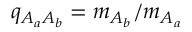<formula> <loc_0><loc_0><loc_500><loc_500>q _ { A _ { a } A _ { b } } = m _ { A _ { b } } / m _ { A _ { a } }</formula> 